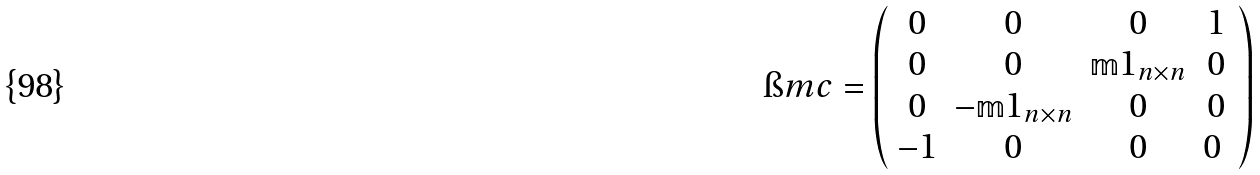Convert formula to latex. <formula><loc_0><loc_0><loc_500><loc_500>\i m c = \left ( \begin{array} { c c c c } 0 & 0 & 0 & 1 \\ 0 & 0 & \mathbb { m } { 1 } _ { n \times n } & 0 \\ 0 & - \mathbb { m } { 1 } _ { n \times n } & 0 & 0 \\ - 1 & 0 & 0 & 0 \ \end{array} \right )</formula> 